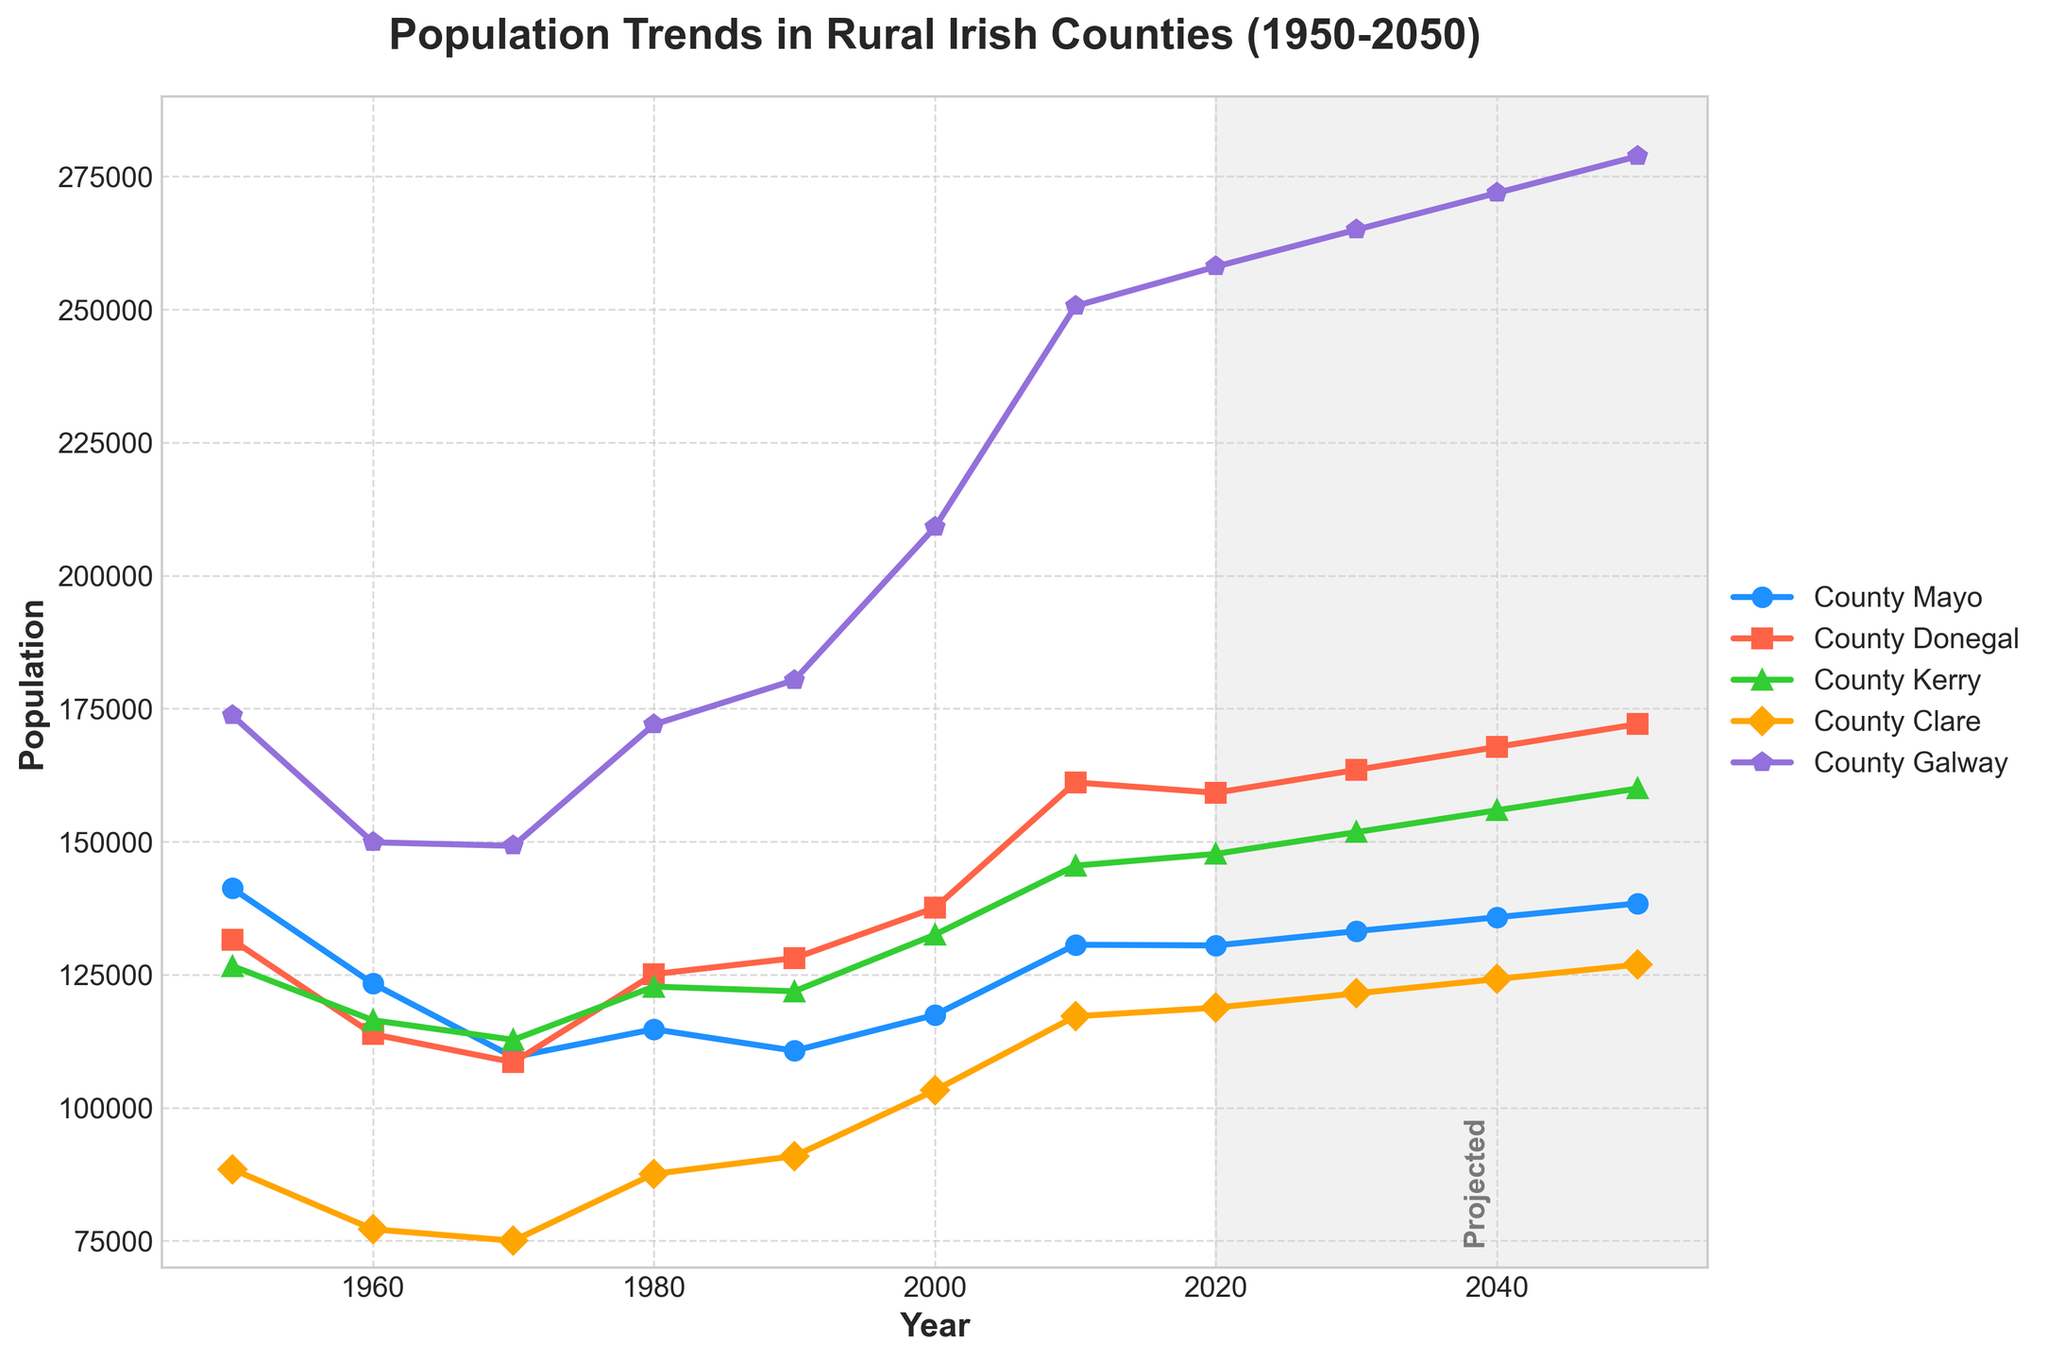How has the population of County Galway changed from 1950 to 2050? To find this, take the population of County Galway in 1950 (173,714) and compare it to the projected population in 2050 (278,800). The difference is 278,800 - 173,714 = 105,086.
Answer: 105,086 Which county had the highest population in 2020? To determine this, look at the population values for all counties in 2020. County Galway had the highest with 258,058.
Answer: County Galway Between 1950 and 2020, which county experienced the largest decrease in population? Calculate the population difference for each county between 1950 and 2020 and identify the largest decrease. For County Mayo: 141,227 - 130,507 = 10,720; County Donegal: 131,530 - 159,192 = -27,662 (increase); County Kerry: 126,644 - 147,707 = -21,063 (increase); County Clare: 88,460 - 118,817 = -30,357 (increase); County Galway: 173,714 - 258,058 = -84,344 (increase). Thus, County Mayo had the largest decrease.
Answer: County Mayo What is the projected population growth for County Mayo and County Kerry between 2020 and 2050? Calculate the projected growth for each county from 2020 to 2050. For County Mayo: 138,400 - 130,507 = 7,893. For County Kerry: 160,000 - 147,707 = 12,293. Add the two: 7,893 + 12,293 = 20,186.
Answer: 20,186 In which year did the population of County Clare first exceed 100,000? Examine the population values for County Clare over the years and identify when it first crossed 100,000. County Clare exceeded 100,000 in 2000 with 103,277.
Answer: 2000 Which county showed the most consistent growth from 1950 to 2050, based on visual trends? By visually examining the trends, County Galway shows a consistent upward growth pattern from 1950 to 2050 without significant dips or fluctuations.
Answer: County Galway What is the difference between the population of County Donegal and County Clare in 2050? Subtract the population of County Clare from that of County Donegal in 2050. 172,100 (Donegal) - 126,900 (Clare) = 45,200.
Answer: 45,200 Which county's population surpassed 200,000 after 2000 and continues to grow steadily? Looking at the trends, County Galway’s population surpassed 200,000 after 2000 and continues to grow steadily, reaching 258,058 in 2020 and projected to be 278,800 by 2050.
Answer: County Galway How many counties had a declining population between 1950 and 1970? Identify the counties by calculating the population changes from 1950 to 1970. County Mayo: 141,227 - 109,525 = 31,702 (decline); County Donegal: 131,530 - 108,549 = 22,981 (decline); County Kerry: 126,644 - 112,772 = 13,872 (decline); County Clare: 88,460 - 75,008 = 13,452 (decline); County Galway: 173,714 - 149,223 = 24,491 (decline). All five counties had a declining population.
Answer: 5 counties 